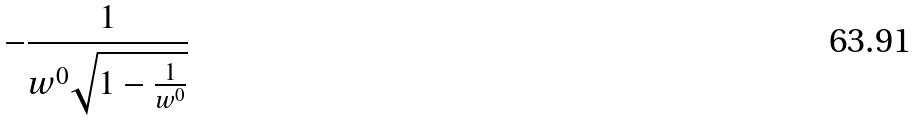Convert formula to latex. <formula><loc_0><loc_0><loc_500><loc_500>- \frac { 1 } { w ^ { 0 } \sqrt { 1 - \frac { 1 } { w ^ { 0 } } } }</formula> 